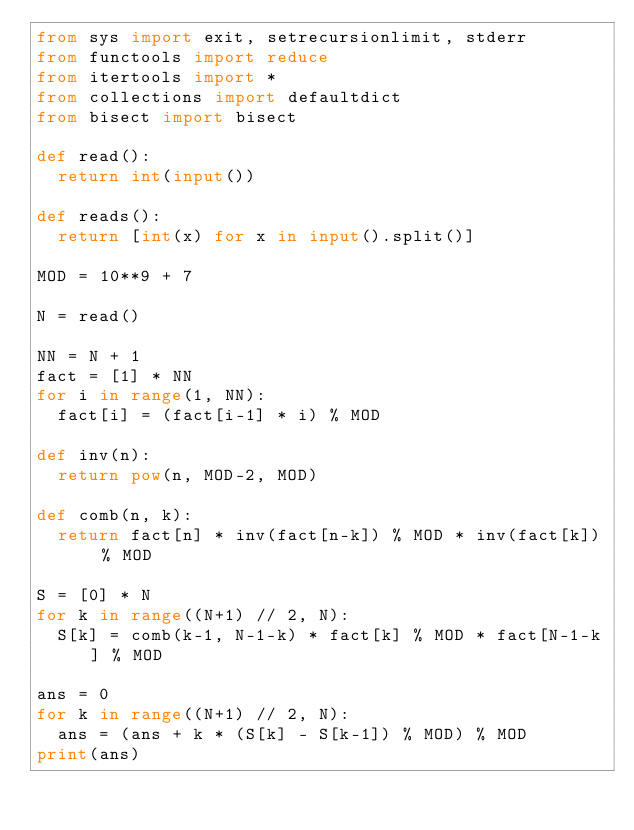Convert code to text. <code><loc_0><loc_0><loc_500><loc_500><_Python_>from sys import exit, setrecursionlimit, stderr
from functools import reduce
from itertools import *
from collections import defaultdict
from bisect import bisect

def read():
  return int(input())

def reads():
  return [int(x) for x in input().split()]

MOD = 10**9 + 7

N = read()

NN = N + 1
fact = [1] * NN
for i in range(1, NN):
  fact[i] = (fact[i-1] * i) % MOD

def inv(n):
  return pow(n, MOD-2, MOD)

def comb(n, k):
  return fact[n] * inv(fact[n-k]) % MOD * inv(fact[k]) % MOD

S = [0] * N
for k in range((N+1) // 2, N):
  S[k] = comb(k-1, N-1-k) * fact[k] % MOD * fact[N-1-k] % MOD

ans = 0
for k in range((N+1) // 2, N):
  ans = (ans + k * (S[k] - S[k-1]) % MOD) % MOD
print(ans)
</code> 